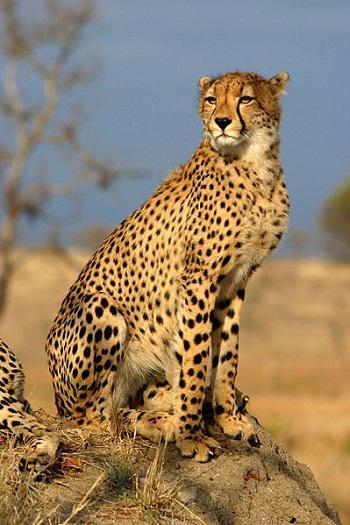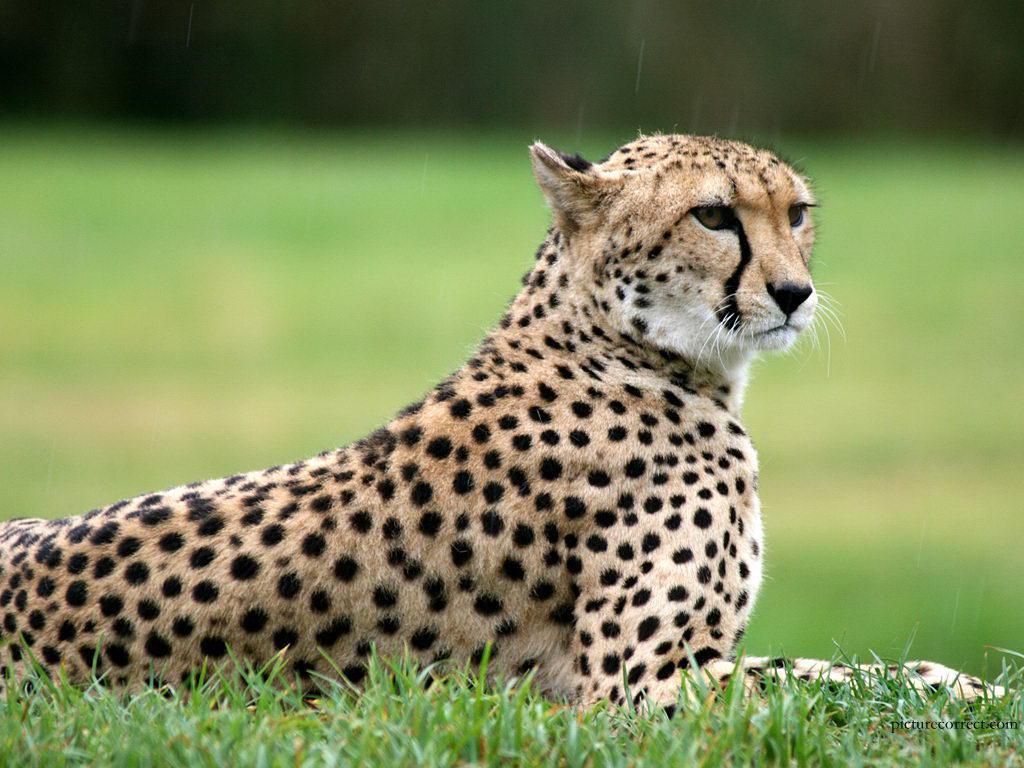The first image is the image on the left, the second image is the image on the right. For the images displayed, is the sentence "There are two cheetahs in the image pair" factually correct? Answer yes or no. Yes. 